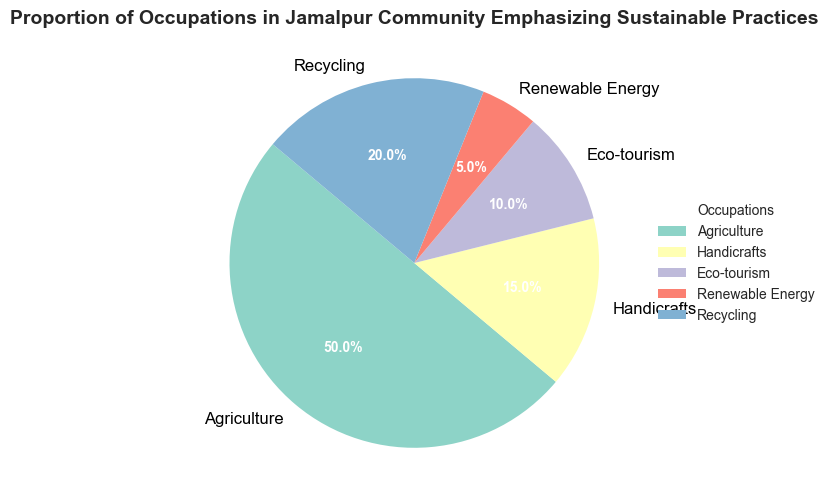What is the largest occupation category in the Jamalpur community? The largest occupation category is the one with the highest percentage in the pie chart. In this case, Agriculture occupies 50% of the pie chart.
Answer: Agriculture What percentage of the Jamalpur community is involved in Eco-tourism? Look at the section of the pie chart labeled Eco-tourism. The label shows that Eco-tourism accounts for 10% of the community occupations.
Answer: 10% How much greater is the proportion of Recycling compared to Renewable Energy? Identify the proportions of Recycling (20%) and Renewable Energy (5%) from the pie chart. Subtract the proportion of Renewable Energy from Recycling (20% - 5% = 15%).
Answer: 15% What are the two smallest occupation categories in the Jamalpur community? The two smallest sections of the pie chart are those with the smallest percentages. In this case, they are Renewable Energy (5%) and Eco-tourism (10%).
Answer: Renewable Energy and Eco-tourism What is the combined percentage of Handicrafts and Recycling occupations? Identify the proportions of Handicrafts (15%) and Recycling (20%) from the pie chart. Add these proportions together (15% + 20% = 35%).
Answer: 35% Which occupation category is represented by a different color than others? Identify all the different colors used in the pie chart. In this case, each occupation category like Agriculture, Handicrafts, Eco-tourism, Renewable Energy, and Recycling is represented by a different color, so there isn't one category with a unique color.
Answer: None If the Handicrafts and Eco-tourism sectors grew by 5% each, what would their new proportions be? Current proportions are Handicrafts (15%) and Eco-tourism (10%). If each grows by 5%, then the new proportions would be Handicrafts (15% + 5% = 20%) and Eco-tourism (10% + 5% = 15%).
Answer: Handicrafts: 20%, Eco-tourism: 15% Which sectors comprise more than half of the total occupations combined? The sectors combined need to exceed 50%. Agriculture is 50% and does not need a combination to exceed 50%. Any additional sectors included with Agriculture would still make this true.
Answer: Agriculture How much smaller is the proportion of Handicrafts than Agriculture? Identify the proportions of Handicrafts (15%) and Agriculture (50%) from the pie chart. Subtract Handicrafts' proportion from Agriculture's (50% - 15% = 35%).
Answer: 35% What is the average proportion of all the occupation categories? Calculate the average by adding all the proportions and dividing by the number of categories: (50% + 15% + 10% + 5% + 20%) / 5 = 100% / 5 = 20%.
Answer: 20% 